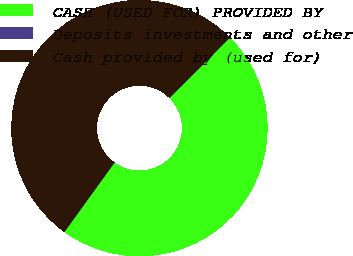Convert chart. <chart><loc_0><loc_0><loc_500><loc_500><pie_chart><fcel>CASH (USED FOR) PROVIDED BY<fcel>Deposits investments and other<fcel>Cash provided by (used for)<nl><fcel>47.45%<fcel>0.01%<fcel>52.54%<nl></chart> 